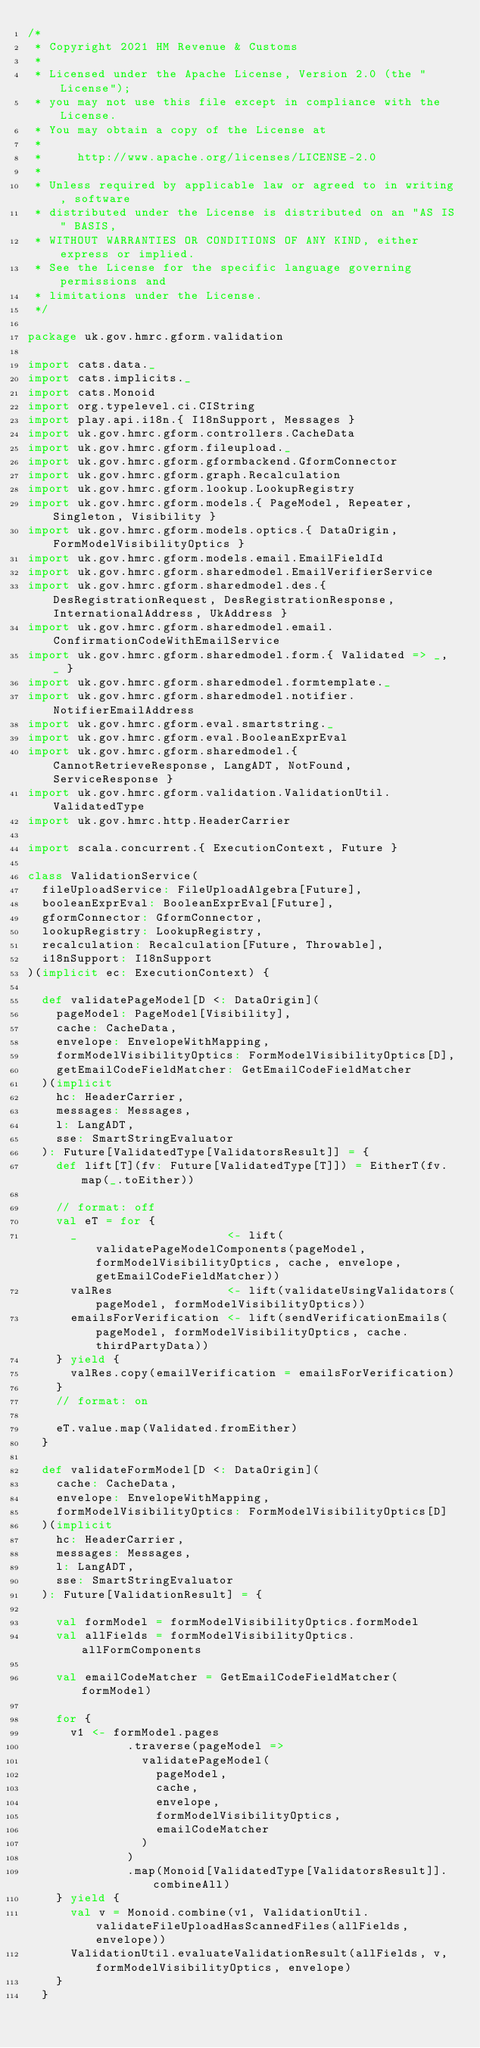Convert code to text. <code><loc_0><loc_0><loc_500><loc_500><_Scala_>/*
 * Copyright 2021 HM Revenue & Customs
 *
 * Licensed under the Apache License, Version 2.0 (the "License");
 * you may not use this file except in compliance with the License.
 * You may obtain a copy of the License at
 *
 *     http://www.apache.org/licenses/LICENSE-2.0
 *
 * Unless required by applicable law or agreed to in writing, software
 * distributed under the License is distributed on an "AS IS" BASIS,
 * WITHOUT WARRANTIES OR CONDITIONS OF ANY KIND, either express or implied.
 * See the License for the specific language governing permissions and
 * limitations under the License.
 */

package uk.gov.hmrc.gform.validation

import cats.data._
import cats.implicits._
import cats.Monoid
import org.typelevel.ci.CIString
import play.api.i18n.{ I18nSupport, Messages }
import uk.gov.hmrc.gform.controllers.CacheData
import uk.gov.hmrc.gform.fileupload._
import uk.gov.hmrc.gform.gformbackend.GformConnector
import uk.gov.hmrc.gform.graph.Recalculation
import uk.gov.hmrc.gform.lookup.LookupRegistry
import uk.gov.hmrc.gform.models.{ PageModel, Repeater, Singleton, Visibility }
import uk.gov.hmrc.gform.models.optics.{ DataOrigin, FormModelVisibilityOptics }
import uk.gov.hmrc.gform.models.email.EmailFieldId
import uk.gov.hmrc.gform.sharedmodel.EmailVerifierService
import uk.gov.hmrc.gform.sharedmodel.des.{ DesRegistrationRequest, DesRegistrationResponse, InternationalAddress, UkAddress }
import uk.gov.hmrc.gform.sharedmodel.email.ConfirmationCodeWithEmailService
import uk.gov.hmrc.gform.sharedmodel.form.{ Validated => _, _ }
import uk.gov.hmrc.gform.sharedmodel.formtemplate._
import uk.gov.hmrc.gform.sharedmodel.notifier.NotifierEmailAddress
import uk.gov.hmrc.gform.eval.smartstring._
import uk.gov.hmrc.gform.eval.BooleanExprEval
import uk.gov.hmrc.gform.sharedmodel.{ CannotRetrieveResponse, LangADT, NotFound, ServiceResponse }
import uk.gov.hmrc.gform.validation.ValidationUtil.ValidatedType
import uk.gov.hmrc.http.HeaderCarrier

import scala.concurrent.{ ExecutionContext, Future }

class ValidationService(
  fileUploadService: FileUploadAlgebra[Future],
  booleanExprEval: BooleanExprEval[Future],
  gformConnector: GformConnector,
  lookupRegistry: LookupRegistry,
  recalculation: Recalculation[Future, Throwable],
  i18nSupport: I18nSupport
)(implicit ec: ExecutionContext) {

  def validatePageModel[D <: DataOrigin](
    pageModel: PageModel[Visibility],
    cache: CacheData,
    envelope: EnvelopeWithMapping,
    formModelVisibilityOptics: FormModelVisibilityOptics[D],
    getEmailCodeFieldMatcher: GetEmailCodeFieldMatcher
  )(implicit
    hc: HeaderCarrier,
    messages: Messages,
    l: LangADT,
    sse: SmartStringEvaluator
  ): Future[ValidatedType[ValidatorsResult]] = {
    def lift[T](fv: Future[ValidatedType[T]]) = EitherT(fv.map(_.toEither))

    // format: off
    val eT = for {
      _                     <- lift(validatePageModelComponents(pageModel, formModelVisibilityOptics, cache, envelope, getEmailCodeFieldMatcher))
      valRes                <- lift(validateUsingValidators(pageModel, formModelVisibilityOptics))
      emailsForVerification <- lift(sendVerificationEmails(pageModel, formModelVisibilityOptics, cache.thirdPartyData))
    } yield {
      valRes.copy(emailVerification = emailsForVerification)
    }
    // format: on

    eT.value.map(Validated.fromEither)
  }

  def validateFormModel[D <: DataOrigin](
    cache: CacheData,
    envelope: EnvelopeWithMapping,
    formModelVisibilityOptics: FormModelVisibilityOptics[D]
  )(implicit
    hc: HeaderCarrier,
    messages: Messages,
    l: LangADT,
    sse: SmartStringEvaluator
  ): Future[ValidationResult] = {

    val formModel = formModelVisibilityOptics.formModel
    val allFields = formModelVisibilityOptics.allFormComponents

    val emailCodeMatcher = GetEmailCodeFieldMatcher(formModel)

    for {
      v1 <- formModel.pages
              .traverse(pageModel =>
                validatePageModel(
                  pageModel,
                  cache,
                  envelope,
                  formModelVisibilityOptics,
                  emailCodeMatcher
                )
              )
              .map(Monoid[ValidatedType[ValidatorsResult]].combineAll)
    } yield {
      val v = Monoid.combine(v1, ValidationUtil.validateFileUploadHasScannedFiles(allFields, envelope))
      ValidationUtil.evaluateValidationResult(allFields, v, formModelVisibilityOptics, envelope)
    }
  }
</code> 